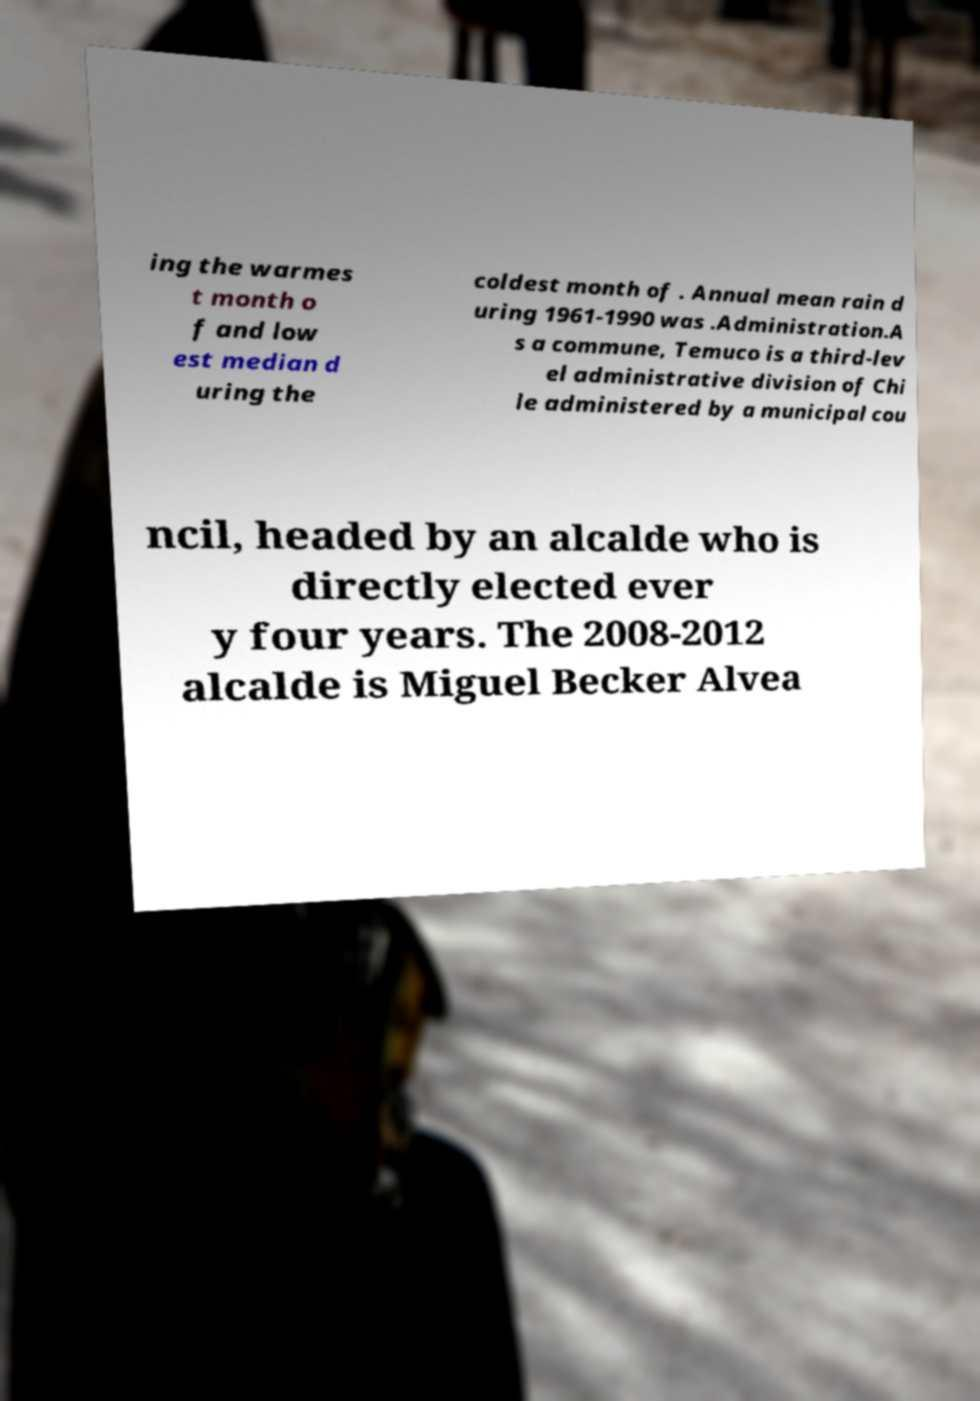I need the written content from this picture converted into text. Can you do that? ing the warmes t month o f and low est median d uring the coldest month of . Annual mean rain d uring 1961-1990 was .Administration.A s a commune, Temuco is a third-lev el administrative division of Chi le administered by a municipal cou ncil, headed by an alcalde who is directly elected ever y four years. The 2008-2012 alcalde is Miguel Becker Alvea 